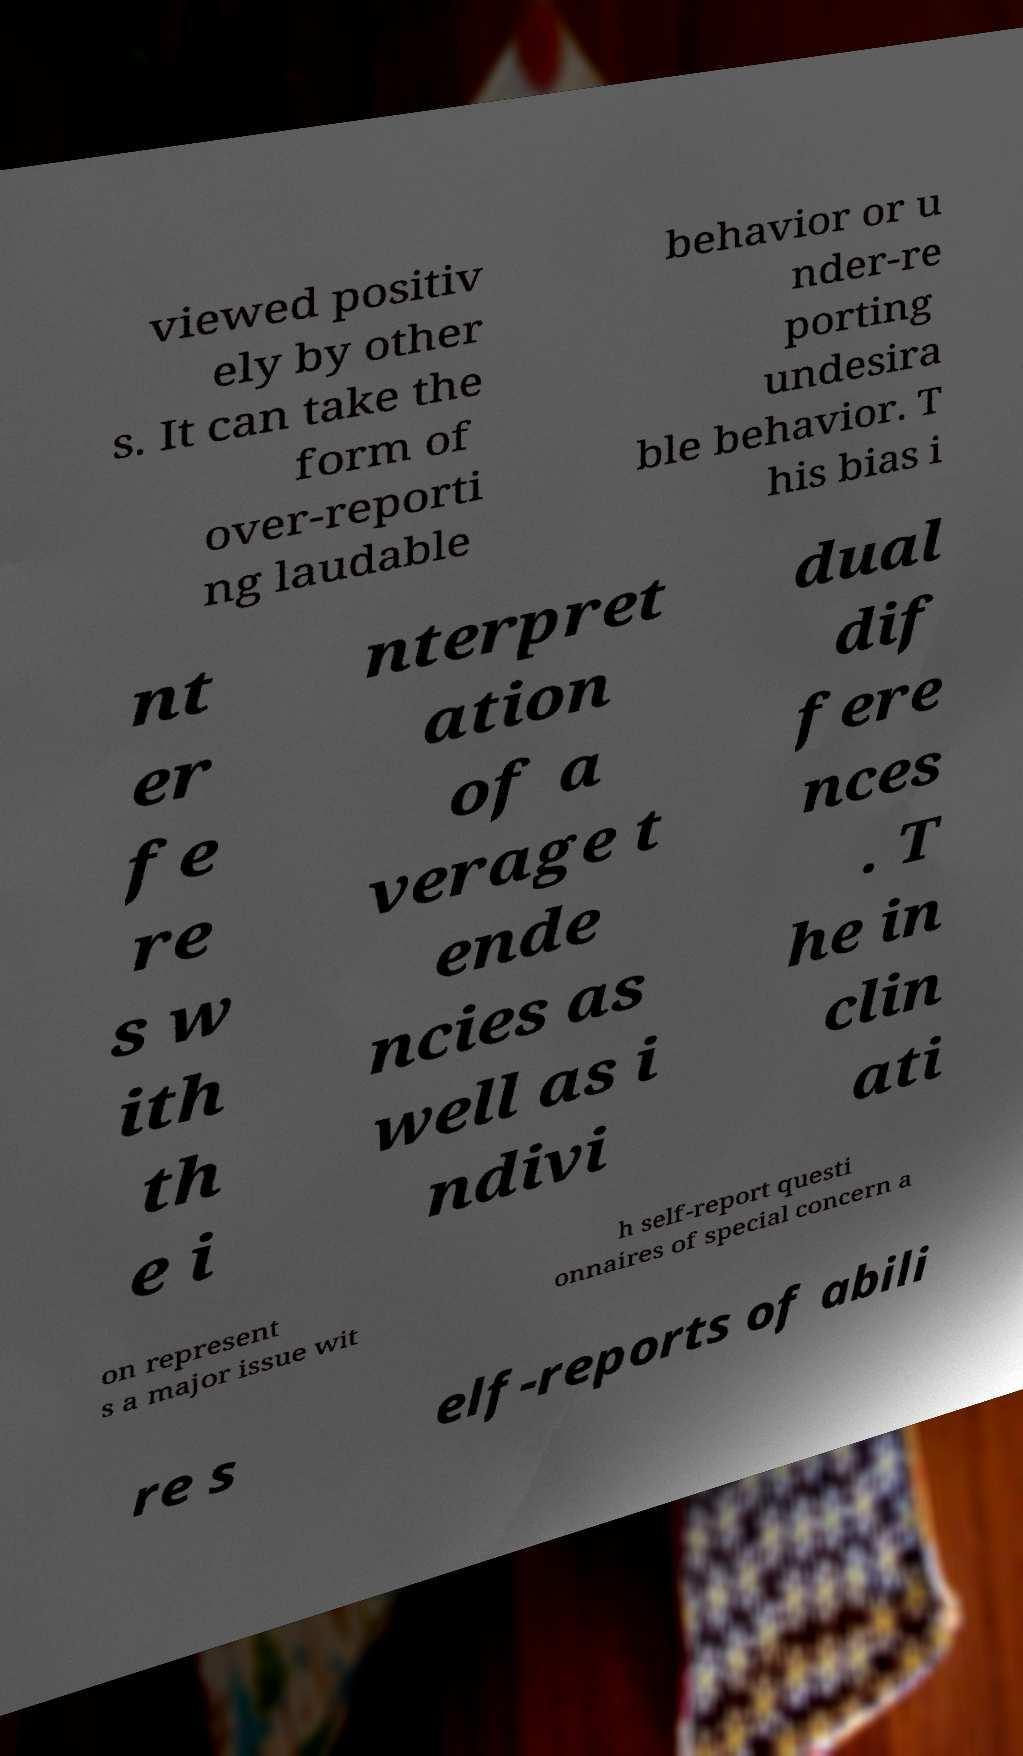Could you extract and type out the text from this image? viewed positiv ely by other s. It can take the form of over-reporti ng laudable behavior or u nder-re porting undesira ble behavior. T his bias i nt er fe re s w ith th e i nterpret ation of a verage t ende ncies as well as i ndivi dual dif fere nces . T he in clin ati on represent s a major issue wit h self-report questi onnaires of special concern a re s elf-reports of abili 